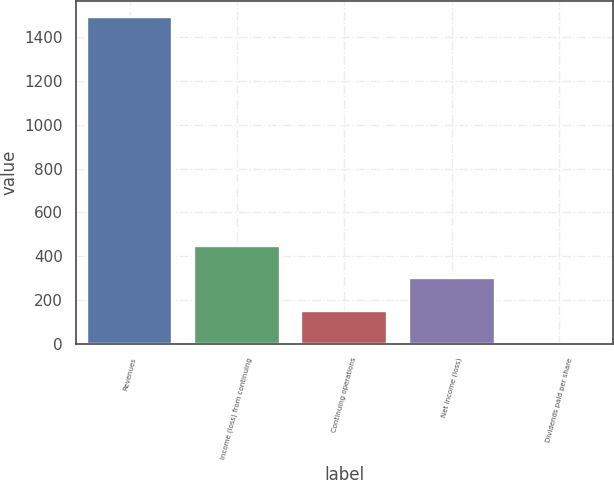Convert chart. <chart><loc_0><loc_0><loc_500><loc_500><bar_chart><fcel>Revenues<fcel>Income (loss) from continuing<fcel>Continuing operations<fcel>Net income (loss)<fcel>Dividends paid per share<nl><fcel>1490<fcel>447.15<fcel>149.19<fcel>298.17<fcel>0.21<nl></chart> 